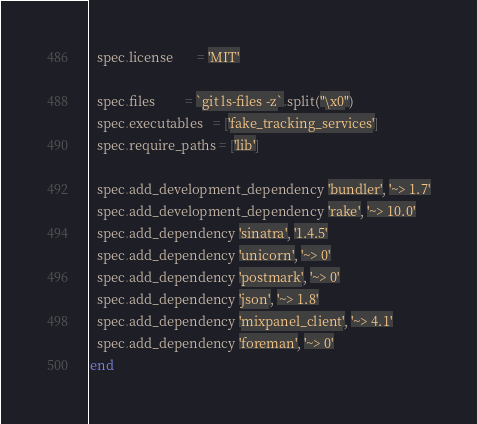Convert code to text. <code><loc_0><loc_0><loc_500><loc_500><_Ruby_>  spec.license       = 'MIT'

  spec.files         = `git ls-files -z`.split("\x0")
  spec.executables   = ['fake_tracking_services']
  spec.require_paths = ['lib']

  spec.add_development_dependency 'bundler', '~> 1.7'
  spec.add_development_dependency 'rake', '~> 10.0'
  spec.add_dependency 'sinatra', '1.4.5'
  spec.add_dependency 'unicorn', '~> 0'
  spec.add_dependency 'postmark', '~> 0'
  spec.add_dependency 'json', '~> 1.8'
  spec.add_dependency 'mixpanel_client', '~> 4.1'
  spec.add_dependency 'foreman', '~> 0'
end
</code> 